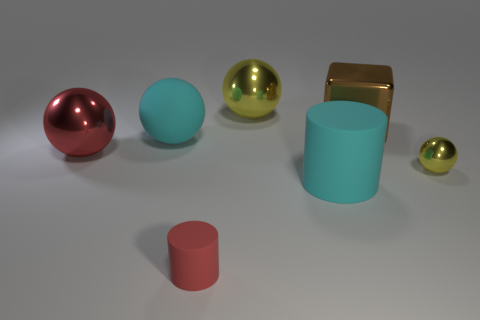Does the big matte sphere have the same color as the large cylinder?
Your response must be concise. Yes. What number of cylinders are small rubber things or tiny objects?
Your answer should be compact. 1. The large ball that is both behind the red ball and on the left side of the red rubber cylinder is made of what material?
Offer a terse response. Rubber. There is a brown shiny block; how many big balls are in front of it?
Offer a very short reply. 2. Is the large ball left of the large cyan rubber ball made of the same material as the cyan ball that is to the left of the brown cube?
Provide a short and direct response. No. What number of things are big metallic balls on the left side of the small red thing or big matte cylinders?
Give a very brief answer. 2. Is the number of small rubber things behind the small yellow thing less than the number of shiny things that are on the left side of the large rubber cylinder?
Offer a terse response. Yes. What number of other things are there of the same size as the red cylinder?
Ensure brevity in your answer.  1. Are the big yellow thing and the tiny thing to the right of the small cylinder made of the same material?
Your answer should be very brief. Yes. What number of objects are shiny objects that are right of the small rubber cylinder or yellow spheres behind the brown object?
Provide a succinct answer. 3. 